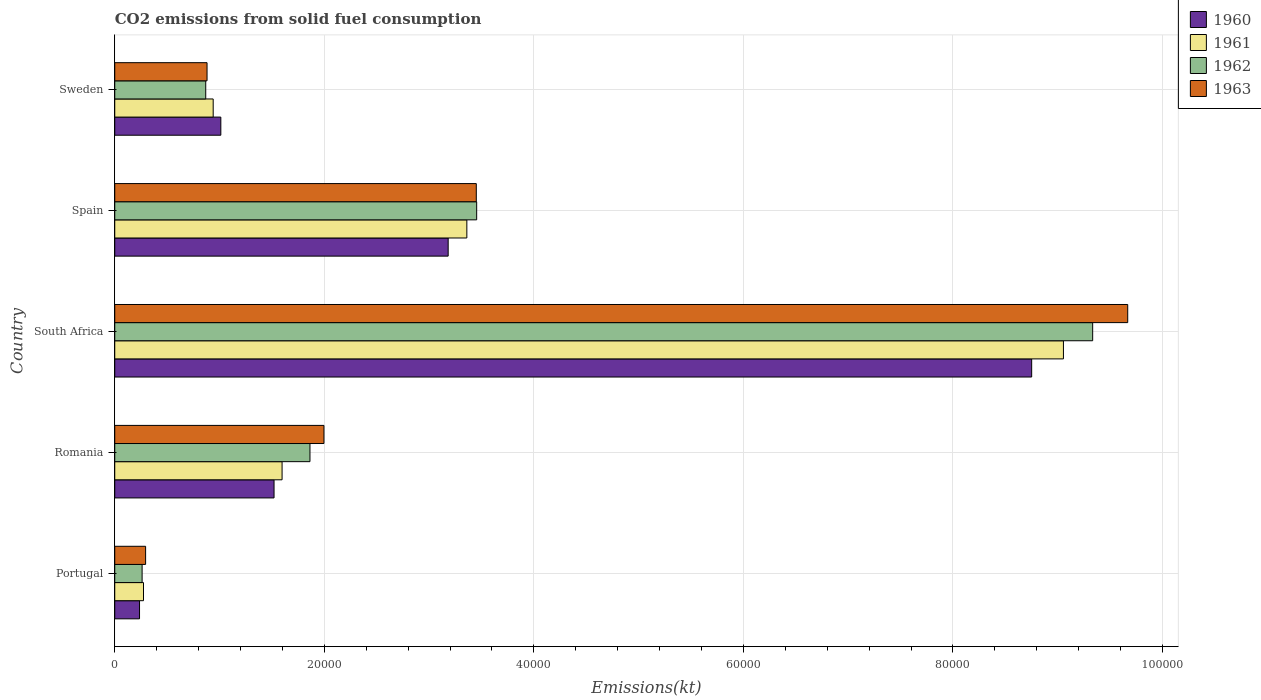How many groups of bars are there?
Give a very brief answer. 5. Are the number of bars on each tick of the Y-axis equal?
Provide a short and direct response. Yes. How many bars are there on the 2nd tick from the bottom?
Your answer should be compact. 4. What is the label of the 3rd group of bars from the top?
Offer a very short reply. South Africa. In how many cases, is the number of bars for a given country not equal to the number of legend labels?
Give a very brief answer. 0. What is the amount of CO2 emitted in 1962 in Romania?
Keep it short and to the point. 1.86e+04. Across all countries, what is the maximum amount of CO2 emitted in 1961?
Offer a very short reply. 9.05e+04. Across all countries, what is the minimum amount of CO2 emitted in 1961?
Provide a short and direct response. 2742.92. In which country was the amount of CO2 emitted in 1961 maximum?
Keep it short and to the point. South Africa. In which country was the amount of CO2 emitted in 1960 minimum?
Your answer should be very brief. Portugal. What is the total amount of CO2 emitted in 1961 in the graph?
Offer a very short reply. 1.52e+05. What is the difference between the amount of CO2 emitted in 1961 in Portugal and that in Sweden?
Provide a short and direct response. -6651.94. What is the difference between the amount of CO2 emitted in 1963 in Sweden and the amount of CO2 emitted in 1960 in South Africa?
Ensure brevity in your answer.  -7.87e+04. What is the average amount of CO2 emitted in 1961 per country?
Make the answer very short. 3.05e+04. What is the difference between the amount of CO2 emitted in 1963 and amount of CO2 emitted in 1962 in Portugal?
Provide a succinct answer. 333.7. In how many countries, is the amount of CO2 emitted in 1962 greater than 24000 kt?
Offer a very short reply. 2. What is the ratio of the amount of CO2 emitted in 1961 in Portugal to that in Romania?
Keep it short and to the point. 0.17. Is the amount of CO2 emitted in 1961 in Portugal less than that in Romania?
Give a very brief answer. Yes. Is the difference between the amount of CO2 emitted in 1963 in Portugal and South Africa greater than the difference between the amount of CO2 emitted in 1962 in Portugal and South Africa?
Offer a very short reply. No. What is the difference between the highest and the second highest amount of CO2 emitted in 1961?
Keep it short and to the point. 5.69e+04. What is the difference between the highest and the lowest amount of CO2 emitted in 1963?
Offer a very short reply. 9.37e+04. In how many countries, is the amount of CO2 emitted in 1962 greater than the average amount of CO2 emitted in 1962 taken over all countries?
Your answer should be compact. 2. Is it the case that in every country, the sum of the amount of CO2 emitted in 1960 and amount of CO2 emitted in 1962 is greater than the sum of amount of CO2 emitted in 1963 and amount of CO2 emitted in 1961?
Your answer should be very brief. No. What does the 3rd bar from the top in Sweden represents?
Make the answer very short. 1961. What does the 3rd bar from the bottom in Portugal represents?
Your answer should be compact. 1962. Is it the case that in every country, the sum of the amount of CO2 emitted in 1960 and amount of CO2 emitted in 1963 is greater than the amount of CO2 emitted in 1961?
Give a very brief answer. Yes. How many bars are there?
Ensure brevity in your answer.  20. Are all the bars in the graph horizontal?
Make the answer very short. Yes. What is the difference between two consecutive major ticks on the X-axis?
Offer a terse response. 2.00e+04. How many legend labels are there?
Give a very brief answer. 4. How are the legend labels stacked?
Your answer should be very brief. Vertical. What is the title of the graph?
Keep it short and to the point. CO2 emissions from solid fuel consumption. What is the label or title of the X-axis?
Offer a terse response. Emissions(kt). What is the label or title of the Y-axis?
Keep it short and to the point. Country. What is the Emissions(kt) in 1960 in Portugal?
Provide a succinct answer. 2365.22. What is the Emissions(kt) of 1961 in Portugal?
Ensure brevity in your answer.  2742.92. What is the Emissions(kt) in 1962 in Portugal?
Your answer should be very brief. 2610.9. What is the Emissions(kt) in 1963 in Portugal?
Ensure brevity in your answer.  2944.6. What is the Emissions(kt) in 1960 in Romania?
Make the answer very short. 1.52e+04. What is the Emissions(kt) in 1961 in Romania?
Offer a very short reply. 1.60e+04. What is the Emissions(kt) in 1962 in Romania?
Your answer should be compact. 1.86e+04. What is the Emissions(kt) of 1963 in Romania?
Offer a terse response. 2.00e+04. What is the Emissions(kt) of 1960 in South Africa?
Ensure brevity in your answer.  8.75e+04. What is the Emissions(kt) in 1961 in South Africa?
Your answer should be compact. 9.05e+04. What is the Emissions(kt) of 1962 in South Africa?
Your answer should be compact. 9.33e+04. What is the Emissions(kt) of 1963 in South Africa?
Your answer should be very brief. 9.67e+04. What is the Emissions(kt) of 1960 in Spain?
Provide a succinct answer. 3.18e+04. What is the Emissions(kt) in 1961 in Spain?
Keep it short and to the point. 3.36e+04. What is the Emissions(kt) in 1962 in Spain?
Provide a short and direct response. 3.45e+04. What is the Emissions(kt) of 1963 in Spain?
Your answer should be compact. 3.45e+04. What is the Emissions(kt) of 1960 in Sweden?
Your answer should be compact. 1.01e+04. What is the Emissions(kt) of 1961 in Sweden?
Keep it short and to the point. 9394.85. What is the Emissions(kt) of 1962 in Sweden?
Give a very brief answer. 8683.46. What is the Emissions(kt) of 1963 in Sweden?
Keep it short and to the point. 8808.13. Across all countries, what is the maximum Emissions(kt) in 1960?
Keep it short and to the point. 8.75e+04. Across all countries, what is the maximum Emissions(kt) of 1961?
Your answer should be very brief. 9.05e+04. Across all countries, what is the maximum Emissions(kt) of 1962?
Your response must be concise. 9.33e+04. Across all countries, what is the maximum Emissions(kt) of 1963?
Provide a short and direct response. 9.67e+04. Across all countries, what is the minimum Emissions(kt) in 1960?
Keep it short and to the point. 2365.22. Across all countries, what is the minimum Emissions(kt) in 1961?
Provide a short and direct response. 2742.92. Across all countries, what is the minimum Emissions(kt) of 1962?
Give a very brief answer. 2610.9. Across all countries, what is the minimum Emissions(kt) of 1963?
Your answer should be compact. 2944.6. What is the total Emissions(kt) in 1960 in the graph?
Make the answer very short. 1.47e+05. What is the total Emissions(kt) in 1961 in the graph?
Your answer should be compact. 1.52e+05. What is the total Emissions(kt) of 1962 in the graph?
Give a very brief answer. 1.58e+05. What is the total Emissions(kt) in 1963 in the graph?
Provide a short and direct response. 1.63e+05. What is the difference between the Emissions(kt) in 1960 in Portugal and that in Romania?
Offer a terse response. -1.28e+04. What is the difference between the Emissions(kt) of 1961 in Portugal and that in Romania?
Give a very brief answer. -1.32e+04. What is the difference between the Emissions(kt) in 1962 in Portugal and that in Romania?
Offer a very short reply. -1.60e+04. What is the difference between the Emissions(kt) in 1963 in Portugal and that in Romania?
Ensure brevity in your answer.  -1.70e+04. What is the difference between the Emissions(kt) of 1960 in Portugal and that in South Africa?
Provide a short and direct response. -8.51e+04. What is the difference between the Emissions(kt) in 1961 in Portugal and that in South Africa?
Keep it short and to the point. -8.78e+04. What is the difference between the Emissions(kt) of 1962 in Portugal and that in South Africa?
Make the answer very short. -9.07e+04. What is the difference between the Emissions(kt) of 1963 in Portugal and that in South Africa?
Make the answer very short. -9.37e+04. What is the difference between the Emissions(kt) of 1960 in Portugal and that in Spain?
Provide a succinct answer. -2.95e+04. What is the difference between the Emissions(kt) in 1961 in Portugal and that in Spain?
Offer a terse response. -3.09e+04. What is the difference between the Emissions(kt) in 1962 in Portugal and that in Spain?
Offer a very short reply. -3.19e+04. What is the difference between the Emissions(kt) of 1963 in Portugal and that in Spain?
Offer a terse response. -3.16e+04. What is the difference between the Emissions(kt) in 1960 in Portugal and that in Sweden?
Give a very brief answer. -7759.37. What is the difference between the Emissions(kt) in 1961 in Portugal and that in Sweden?
Ensure brevity in your answer.  -6651.94. What is the difference between the Emissions(kt) in 1962 in Portugal and that in Sweden?
Your answer should be very brief. -6072.55. What is the difference between the Emissions(kt) in 1963 in Portugal and that in Sweden?
Ensure brevity in your answer.  -5863.53. What is the difference between the Emissions(kt) in 1960 in Romania and that in South Africa?
Offer a very short reply. -7.23e+04. What is the difference between the Emissions(kt) in 1961 in Romania and that in South Africa?
Provide a succinct answer. -7.46e+04. What is the difference between the Emissions(kt) of 1962 in Romania and that in South Africa?
Offer a terse response. -7.47e+04. What is the difference between the Emissions(kt) in 1963 in Romania and that in South Africa?
Give a very brief answer. -7.67e+04. What is the difference between the Emissions(kt) of 1960 in Romania and that in Spain?
Offer a very short reply. -1.66e+04. What is the difference between the Emissions(kt) in 1961 in Romania and that in Spain?
Give a very brief answer. -1.76e+04. What is the difference between the Emissions(kt) in 1962 in Romania and that in Spain?
Make the answer very short. -1.59e+04. What is the difference between the Emissions(kt) in 1963 in Romania and that in Spain?
Ensure brevity in your answer.  -1.45e+04. What is the difference between the Emissions(kt) of 1960 in Romania and that in Sweden?
Ensure brevity in your answer.  5078.8. What is the difference between the Emissions(kt) of 1961 in Romania and that in Sweden?
Provide a succinct answer. 6574.93. What is the difference between the Emissions(kt) of 1962 in Romania and that in Sweden?
Make the answer very short. 9948.57. What is the difference between the Emissions(kt) of 1963 in Romania and that in Sweden?
Provide a short and direct response. 1.12e+04. What is the difference between the Emissions(kt) of 1960 in South Africa and that in Spain?
Your response must be concise. 5.57e+04. What is the difference between the Emissions(kt) in 1961 in South Africa and that in Spain?
Your answer should be very brief. 5.69e+04. What is the difference between the Emissions(kt) of 1962 in South Africa and that in Spain?
Offer a very short reply. 5.88e+04. What is the difference between the Emissions(kt) in 1963 in South Africa and that in Spain?
Keep it short and to the point. 6.22e+04. What is the difference between the Emissions(kt) in 1960 in South Africa and that in Sweden?
Provide a succinct answer. 7.74e+04. What is the difference between the Emissions(kt) of 1961 in South Africa and that in Sweden?
Give a very brief answer. 8.12e+04. What is the difference between the Emissions(kt) in 1962 in South Africa and that in Sweden?
Give a very brief answer. 8.47e+04. What is the difference between the Emissions(kt) of 1963 in South Africa and that in Sweden?
Provide a short and direct response. 8.79e+04. What is the difference between the Emissions(kt) of 1960 in Spain and that in Sweden?
Offer a very short reply. 2.17e+04. What is the difference between the Emissions(kt) of 1961 in Spain and that in Sweden?
Offer a very short reply. 2.42e+04. What is the difference between the Emissions(kt) in 1962 in Spain and that in Sweden?
Keep it short and to the point. 2.59e+04. What is the difference between the Emissions(kt) of 1963 in Spain and that in Sweden?
Keep it short and to the point. 2.57e+04. What is the difference between the Emissions(kt) of 1960 in Portugal and the Emissions(kt) of 1961 in Romania?
Ensure brevity in your answer.  -1.36e+04. What is the difference between the Emissions(kt) in 1960 in Portugal and the Emissions(kt) in 1962 in Romania?
Provide a short and direct response. -1.63e+04. What is the difference between the Emissions(kt) in 1960 in Portugal and the Emissions(kt) in 1963 in Romania?
Your response must be concise. -1.76e+04. What is the difference between the Emissions(kt) in 1961 in Portugal and the Emissions(kt) in 1962 in Romania?
Keep it short and to the point. -1.59e+04. What is the difference between the Emissions(kt) of 1961 in Portugal and the Emissions(kt) of 1963 in Romania?
Your response must be concise. -1.72e+04. What is the difference between the Emissions(kt) of 1962 in Portugal and the Emissions(kt) of 1963 in Romania?
Provide a succinct answer. -1.74e+04. What is the difference between the Emissions(kt) in 1960 in Portugal and the Emissions(kt) in 1961 in South Africa?
Your answer should be compact. -8.82e+04. What is the difference between the Emissions(kt) in 1960 in Portugal and the Emissions(kt) in 1962 in South Africa?
Make the answer very short. -9.10e+04. What is the difference between the Emissions(kt) in 1960 in Portugal and the Emissions(kt) in 1963 in South Africa?
Your answer should be very brief. -9.43e+04. What is the difference between the Emissions(kt) of 1961 in Portugal and the Emissions(kt) of 1962 in South Africa?
Offer a terse response. -9.06e+04. What is the difference between the Emissions(kt) in 1961 in Portugal and the Emissions(kt) in 1963 in South Africa?
Provide a succinct answer. -9.39e+04. What is the difference between the Emissions(kt) in 1962 in Portugal and the Emissions(kt) in 1963 in South Africa?
Make the answer very short. -9.41e+04. What is the difference between the Emissions(kt) in 1960 in Portugal and the Emissions(kt) in 1961 in Spain?
Your answer should be compact. -3.12e+04. What is the difference between the Emissions(kt) in 1960 in Portugal and the Emissions(kt) in 1962 in Spain?
Your response must be concise. -3.22e+04. What is the difference between the Emissions(kt) in 1960 in Portugal and the Emissions(kt) in 1963 in Spain?
Provide a short and direct response. -3.21e+04. What is the difference between the Emissions(kt) in 1961 in Portugal and the Emissions(kt) in 1962 in Spain?
Your response must be concise. -3.18e+04. What is the difference between the Emissions(kt) of 1961 in Portugal and the Emissions(kt) of 1963 in Spain?
Offer a very short reply. -3.18e+04. What is the difference between the Emissions(kt) in 1962 in Portugal and the Emissions(kt) in 1963 in Spain?
Offer a terse response. -3.19e+04. What is the difference between the Emissions(kt) in 1960 in Portugal and the Emissions(kt) in 1961 in Sweden?
Give a very brief answer. -7029.64. What is the difference between the Emissions(kt) in 1960 in Portugal and the Emissions(kt) in 1962 in Sweden?
Keep it short and to the point. -6318.24. What is the difference between the Emissions(kt) in 1960 in Portugal and the Emissions(kt) in 1963 in Sweden?
Your answer should be compact. -6442.92. What is the difference between the Emissions(kt) in 1961 in Portugal and the Emissions(kt) in 1962 in Sweden?
Keep it short and to the point. -5940.54. What is the difference between the Emissions(kt) of 1961 in Portugal and the Emissions(kt) of 1963 in Sweden?
Your answer should be compact. -6065.22. What is the difference between the Emissions(kt) of 1962 in Portugal and the Emissions(kt) of 1963 in Sweden?
Give a very brief answer. -6197.23. What is the difference between the Emissions(kt) in 1960 in Romania and the Emissions(kt) in 1961 in South Africa?
Make the answer very short. -7.53e+04. What is the difference between the Emissions(kt) of 1960 in Romania and the Emissions(kt) of 1962 in South Africa?
Your answer should be very brief. -7.81e+04. What is the difference between the Emissions(kt) in 1960 in Romania and the Emissions(kt) in 1963 in South Africa?
Provide a short and direct response. -8.15e+04. What is the difference between the Emissions(kt) in 1961 in Romania and the Emissions(kt) in 1962 in South Africa?
Give a very brief answer. -7.74e+04. What is the difference between the Emissions(kt) of 1961 in Romania and the Emissions(kt) of 1963 in South Africa?
Make the answer very short. -8.07e+04. What is the difference between the Emissions(kt) in 1962 in Romania and the Emissions(kt) in 1963 in South Africa?
Your answer should be compact. -7.80e+04. What is the difference between the Emissions(kt) in 1960 in Romania and the Emissions(kt) in 1961 in Spain?
Make the answer very short. -1.84e+04. What is the difference between the Emissions(kt) of 1960 in Romania and the Emissions(kt) of 1962 in Spain?
Give a very brief answer. -1.93e+04. What is the difference between the Emissions(kt) of 1960 in Romania and the Emissions(kt) of 1963 in Spain?
Make the answer very short. -1.93e+04. What is the difference between the Emissions(kt) in 1961 in Romania and the Emissions(kt) in 1962 in Spain?
Your answer should be very brief. -1.86e+04. What is the difference between the Emissions(kt) in 1961 in Romania and the Emissions(kt) in 1963 in Spain?
Offer a very short reply. -1.85e+04. What is the difference between the Emissions(kt) of 1962 in Romania and the Emissions(kt) of 1963 in Spain?
Your response must be concise. -1.59e+04. What is the difference between the Emissions(kt) in 1960 in Romania and the Emissions(kt) in 1961 in Sweden?
Make the answer very short. 5808.53. What is the difference between the Emissions(kt) of 1960 in Romania and the Emissions(kt) of 1962 in Sweden?
Keep it short and to the point. 6519.93. What is the difference between the Emissions(kt) in 1960 in Romania and the Emissions(kt) in 1963 in Sweden?
Keep it short and to the point. 6395.25. What is the difference between the Emissions(kt) of 1961 in Romania and the Emissions(kt) of 1962 in Sweden?
Give a very brief answer. 7286.33. What is the difference between the Emissions(kt) in 1961 in Romania and the Emissions(kt) in 1963 in Sweden?
Give a very brief answer. 7161.65. What is the difference between the Emissions(kt) in 1962 in Romania and the Emissions(kt) in 1963 in Sweden?
Offer a terse response. 9823.89. What is the difference between the Emissions(kt) of 1960 in South Africa and the Emissions(kt) of 1961 in Spain?
Your answer should be compact. 5.39e+04. What is the difference between the Emissions(kt) in 1960 in South Africa and the Emissions(kt) in 1962 in Spain?
Offer a very short reply. 5.30e+04. What is the difference between the Emissions(kt) in 1960 in South Africa and the Emissions(kt) in 1963 in Spain?
Offer a very short reply. 5.30e+04. What is the difference between the Emissions(kt) of 1961 in South Africa and the Emissions(kt) of 1962 in Spain?
Keep it short and to the point. 5.60e+04. What is the difference between the Emissions(kt) of 1961 in South Africa and the Emissions(kt) of 1963 in Spain?
Offer a terse response. 5.60e+04. What is the difference between the Emissions(kt) in 1962 in South Africa and the Emissions(kt) in 1963 in Spain?
Your answer should be very brief. 5.88e+04. What is the difference between the Emissions(kt) of 1960 in South Africa and the Emissions(kt) of 1961 in Sweden?
Ensure brevity in your answer.  7.81e+04. What is the difference between the Emissions(kt) of 1960 in South Africa and the Emissions(kt) of 1962 in Sweden?
Make the answer very short. 7.88e+04. What is the difference between the Emissions(kt) in 1960 in South Africa and the Emissions(kt) in 1963 in Sweden?
Make the answer very short. 7.87e+04. What is the difference between the Emissions(kt) in 1961 in South Africa and the Emissions(kt) in 1962 in Sweden?
Make the answer very short. 8.19e+04. What is the difference between the Emissions(kt) in 1961 in South Africa and the Emissions(kt) in 1963 in Sweden?
Your response must be concise. 8.17e+04. What is the difference between the Emissions(kt) of 1962 in South Africa and the Emissions(kt) of 1963 in Sweden?
Offer a terse response. 8.45e+04. What is the difference between the Emissions(kt) of 1960 in Spain and the Emissions(kt) of 1961 in Sweden?
Provide a succinct answer. 2.24e+04. What is the difference between the Emissions(kt) of 1960 in Spain and the Emissions(kt) of 1962 in Sweden?
Your answer should be very brief. 2.31e+04. What is the difference between the Emissions(kt) in 1960 in Spain and the Emissions(kt) in 1963 in Sweden?
Make the answer very short. 2.30e+04. What is the difference between the Emissions(kt) in 1961 in Spain and the Emissions(kt) in 1962 in Sweden?
Offer a very short reply. 2.49e+04. What is the difference between the Emissions(kt) in 1961 in Spain and the Emissions(kt) in 1963 in Sweden?
Provide a succinct answer. 2.48e+04. What is the difference between the Emissions(kt) of 1962 in Spain and the Emissions(kt) of 1963 in Sweden?
Make the answer very short. 2.57e+04. What is the average Emissions(kt) of 1960 per country?
Give a very brief answer. 2.94e+04. What is the average Emissions(kt) of 1961 per country?
Your answer should be compact. 3.05e+04. What is the average Emissions(kt) in 1962 per country?
Keep it short and to the point. 3.16e+04. What is the average Emissions(kt) in 1963 per country?
Give a very brief answer. 3.26e+04. What is the difference between the Emissions(kt) of 1960 and Emissions(kt) of 1961 in Portugal?
Give a very brief answer. -377.7. What is the difference between the Emissions(kt) in 1960 and Emissions(kt) in 1962 in Portugal?
Provide a succinct answer. -245.69. What is the difference between the Emissions(kt) in 1960 and Emissions(kt) in 1963 in Portugal?
Ensure brevity in your answer.  -579.39. What is the difference between the Emissions(kt) in 1961 and Emissions(kt) in 1962 in Portugal?
Your response must be concise. 132.01. What is the difference between the Emissions(kt) of 1961 and Emissions(kt) of 1963 in Portugal?
Offer a very short reply. -201.69. What is the difference between the Emissions(kt) in 1962 and Emissions(kt) in 1963 in Portugal?
Make the answer very short. -333.7. What is the difference between the Emissions(kt) in 1960 and Emissions(kt) in 1961 in Romania?
Your answer should be compact. -766.4. What is the difference between the Emissions(kt) of 1960 and Emissions(kt) of 1962 in Romania?
Provide a succinct answer. -3428.64. What is the difference between the Emissions(kt) of 1960 and Emissions(kt) of 1963 in Romania?
Your answer should be very brief. -4763.43. What is the difference between the Emissions(kt) of 1961 and Emissions(kt) of 1962 in Romania?
Keep it short and to the point. -2662.24. What is the difference between the Emissions(kt) of 1961 and Emissions(kt) of 1963 in Romania?
Your response must be concise. -3997.03. What is the difference between the Emissions(kt) of 1962 and Emissions(kt) of 1963 in Romania?
Offer a terse response. -1334.79. What is the difference between the Emissions(kt) in 1960 and Emissions(kt) in 1961 in South Africa?
Your answer should be compact. -3032.61. What is the difference between the Emissions(kt) in 1960 and Emissions(kt) in 1962 in South Africa?
Your answer should be compact. -5823.2. What is the difference between the Emissions(kt) in 1960 and Emissions(kt) in 1963 in South Africa?
Your answer should be compact. -9167.5. What is the difference between the Emissions(kt) in 1961 and Emissions(kt) in 1962 in South Africa?
Keep it short and to the point. -2790.59. What is the difference between the Emissions(kt) in 1961 and Emissions(kt) in 1963 in South Africa?
Provide a succinct answer. -6134.89. What is the difference between the Emissions(kt) of 1962 and Emissions(kt) of 1963 in South Africa?
Offer a terse response. -3344.3. What is the difference between the Emissions(kt) of 1960 and Emissions(kt) of 1961 in Spain?
Offer a very short reply. -1782.16. What is the difference between the Emissions(kt) of 1960 and Emissions(kt) of 1962 in Spain?
Offer a terse response. -2720.91. What is the difference between the Emissions(kt) of 1960 and Emissions(kt) of 1963 in Spain?
Your answer should be compact. -2684.24. What is the difference between the Emissions(kt) in 1961 and Emissions(kt) in 1962 in Spain?
Offer a very short reply. -938.75. What is the difference between the Emissions(kt) in 1961 and Emissions(kt) in 1963 in Spain?
Give a very brief answer. -902.08. What is the difference between the Emissions(kt) of 1962 and Emissions(kt) of 1963 in Spain?
Provide a succinct answer. 36.67. What is the difference between the Emissions(kt) of 1960 and Emissions(kt) of 1961 in Sweden?
Provide a short and direct response. 729.73. What is the difference between the Emissions(kt) in 1960 and Emissions(kt) in 1962 in Sweden?
Provide a short and direct response. 1441.13. What is the difference between the Emissions(kt) of 1960 and Emissions(kt) of 1963 in Sweden?
Provide a short and direct response. 1316.45. What is the difference between the Emissions(kt) in 1961 and Emissions(kt) in 1962 in Sweden?
Keep it short and to the point. 711.4. What is the difference between the Emissions(kt) in 1961 and Emissions(kt) in 1963 in Sweden?
Your answer should be compact. 586.72. What is the difference between the Emissions(kt) of 1962 and Emissions(kt) of 1963 in Sweden?
Ensure brevity in your answer.  -124.68. What is the ratio of the Emissions(kt) of 1960 in Portugal to that in Romania?
Provide a short and direct response. 0.16. What is the ratio of the Emissions(kt) in 1961 in Portugal to that in Romania?
Offer a very short reply. 0.17. What is the ratio of the Emissions(kt) in 1962 in Portugal to that in Romania?
Give a very brief answer. 0.14. What is the ratio of the Emissions(kt) of 1963 in Portugal to that in Romania?
Ensure brevity in your answer.  0.15. What is the ratio of the Emissions(kt) in 1960 in Portugal to that in South Africa?
Provide a short and direct response. 0.03. What is the ratio of the Emissions(kt) of 1961 in Portugal to that in South Africa?
Provide a succinct answer. 0.03. What is the ratio of the Emissions(kt) of 1962 in Portugal to that in South Africa?
Keep it short and to the point. 0.03. What is the ratio of the Emissions(kt) of 1963 in Portugal to that in South Africa?
Provide a succinct answer. 0.03. What is the ratio of the Emissions(kt) in 1960 in Portugal to that in Spain?
Your answer should be very brief. 0.07. What is the ratio of the Emissions(kt) in 1961 in Portugal to that in Spain?
Keep it short and to the point. 0.08. What is the ratio of the Emissions(kt) in 1962 in Portugal to that in Spain?
Provide a succinct answer. 0.08. What is the ratio of the Emissions(kt) of 1963 in Portugal to that in Spain?
Give a very brief answer. 0.09. What is the ratio of the Emissions(kt) in 1960 in Portugal to that in Sweden?
Provide a short and direct response. 0.23. What is the ratio of the Emissions(kt) of 1961 in Portugal to that in Sweden?
Provide a succinct answer. 0.29. What is the ratio of the Emissions(kt) in 1962 in Portugal to that in Sweden?
Your answer should be very brief. 0.3. What is the ratio of the Emissions(kt) of 1963 in Portugal to that in Sweden?
Your response must be concise. 0.33. What is the ratio of the Emissions(kt) in 1960 in Romania to that in South Africa?
Keep it short and to the point. 0.17. What is the ratio of the Emissions(kt) of 1961 in Romania to that in South Africa?
Provide a succinct answer. 0.18. What is the ratio of the Emissions(kt) in 1962 in Romania to that in South Africa?
Make the answer very short. 0.2. What is the ratio of the Emissions(kt) of 1963 in Romania to that in South Africa?
Your response must be concise. 0.21. What is the ratio of the Emissions(kt) of 1960 in Romania to that in Spain?
Keep it short and to the point. 0.48. What is the ratio of the Emissions(kt) in 1961 in Romania to that in Spain?
Your answer should be compact. 0.48. What is the ratio of the Emissions(kt) of 1962 in Romania to that in Spain?
Your answer should be very brief. 0.54. What is the ratio of the Emissions(kt) of 1963 in Romania to that in Spain?
Offer a terse response. 0.58. What is the ratio of the Emissions(kt) of 1960 in Romania to that in Sweden?
Provide a short and direct response. 1.5. What is the ratio of the Emissions(kt) of 1961 in Romania to that in Sweden?
Your answer should be compact. 1.7. What is the ratio of the Emissions(kt) of 1962 in Romania to that in Sweden?
Offer a very short reply. 2.15. What is the ratio of the Emissions(kt) of 1963 in Romania to that in Sweden?
Your response must be concise. 2.27. What is the ratio of the Emissions(kt) of 1960 in South Africa to that in Spain?
Provide a short and direct response. 2.75. What is the ratio of the Emissions(kt) of 1961 in South Africa to that in Spain?
Your answer should be compact. 2.69. What is the ratio of the Emissions(kt) of 1962 in South Africa to that in Spain?
Offer a very short reply. 2.7. What is the ratio of the Emissions(kt) of 1963 in South Africa to that in Spain?
Keep it short and to the point. 2.8. What is the ratio of the Emissions(kt) in 1960 in South Africa to that in Sweden?
Keep it short and to the point. 8.64. What is the ratio of the Emissions(kt) in 1961 in South Africa to that in Sweden?
Ensure brevity in your answer.  9.64. What is the ratio of the Emissions(kt) in 1962 in South Africa to that in Sweden?
Provide a short and direct response. 10.75. What is the ratio of the Emissions(kt) of 1963 in South Africa to that in Sweden?
Give a very brief answer. 10.98. What is the ratio of the Emissions(kt) in 1960 in Spain to that in Sweden?
Provide a succinct answer. 3.14. What is the ratio of the Emissions(kt) in 1961 in Spain to that in Sweden?
Provide a succinct answer. 3.58. What is the ratio of the Emissions(kt) of 1962 in Spain to that in Sweden?
Give a very brief answer. 3.98. What is the ratio of the Emissions(kt) of 1963 in Spain to that in Sweden?
Provide a short and direct response. 3.92. What is the difference between the highest and the second highest Emissions(kt) of 1960?
Your answer should be compact. 5.57e+04. What is the difference between the highest and the second highest Emissions(kt) of 1961?
Provide a succinct answer. 5.69e+04. What is the difference between the highest and the second highest Emissions(kt) of 1962?
Your answer should be compact. 5.88e+04. What is the difference between the highest and the second highest Emissions(kt) in 1963?
Keep it short and to the point. 6.22e+04. What is the difference between the highest and the lowest Emissions(kt) in 1960?
Provide a succinct answer. 8.51e+04. What is the difference between the highest and the lowest Emissions(kt) of 1961?
Offer a terse response. 8.78e+04. What is the difference between the highest and the lowest Emissions(kt) in 1962?
Make the answer very short. 9.07e+04. What is the difference between the highest and the lowest Emissions(kt) in 1963?
Ensure brevity in your answer.  9.37e+04. 